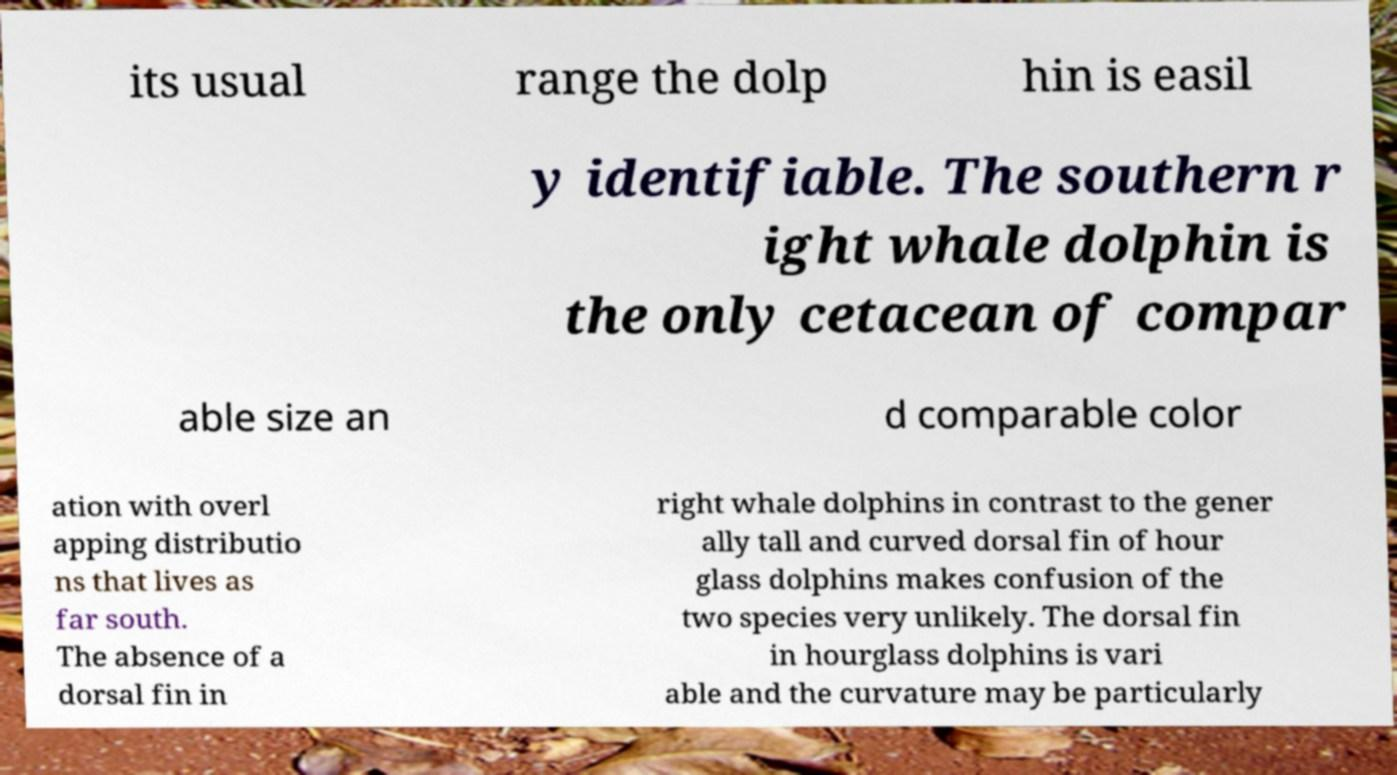For documentation purposes, I need the text within this image transcribed. Could you provide that? its usual range the dolp hin is easil y identifiable. The southern r ight whale dolphin is the only cetacean of compar able size an d comparable color ation with overl apping distributio ns that lives as far south. The absence of a dorsal fin in right whale dolphins in contrast to the gener ally tall and curved dorsal fin of hour glass dolphins makes confusion of the two species very unlikely. The dorsal fin in hourglass dolphins is vari able and the curvature may be particularly 